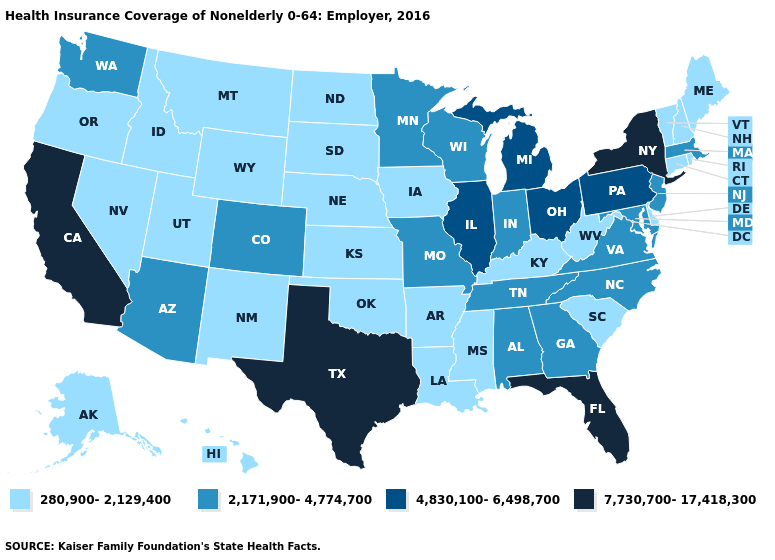Does the map have missing data?
Keep it brief. No. Name the states that have a value in the range 280,900-2,129,400?
Give a very brief answer. Alaska, Arkansas, Connecticut, Delaware, Hawaii, Idaho, Iowa, Kansas, Kentucky, Louisiana, Maine, Mississippi, Montana, Nebraska, Nevada, New Hampshire, New Mexico, North Dakota, Oklahoma, Oregon, Rhode Island, South Carolina, South Dakota, Utah, Vermont, West Virginia, Wyoming. Does Hawaii have the highest value in the West?
Keep it brief. No. Name the states that have a value in the range 7,730,700-17,418,300?
Give a very brief answer. California, Florida, New York, Texas. Does Alabama have a lower value than New York?
Write a very short answer. Yes. Name the states that have a value in the range 7,730,700-17,418,300?
Short answer required. California, Florida, New York, Texas. Name the states that have a value in the range 7,730,700-17,418,300?
Answer briefly. California, Florida, New York, Texas. What is the value of Missouri?
Quick response, please. 2,171,900-4,774,700. Name the states that have a value in the range 2,171,900-4,774,700?
Write a very short answer. Alabama, Arizona, Colorado, Georgia, Indiana, Maryland, Massachusetts, Minnesota, Missouri, New Jersey, North Carolina, Tennessee, Virginia, Washington, Wisconsin. What is the value of North Carolina?
Short answer required. 2,171,900-4,774,700. Among the states that border Florida , which have the lowest value?
Short answer required. Alabama, Georgia. Does Texas have the highest value in the USA?
Give a very brief answer. Yes. Does Florida have the lowest value in the South?
Short answer required. No. Which states have the lowest value in the USA?
Write a very short answer. Alaska, Arkansas, Connecticut, Delaware, Hawaii, Idaho, Iowa, Kansas, Kentucky, Louisiana, Maine, Mississippi, Montana, Nebraska, Nevada, New Hampshire, New Mexico, North Dakota, Oklahoma, Oregon, Rhode Island, South Carolina, South Dakota, Utah, Vermont, West Virginia, Wyoming. What is the value of Montana?
Keep it brief. 280,900-2,129,400. 